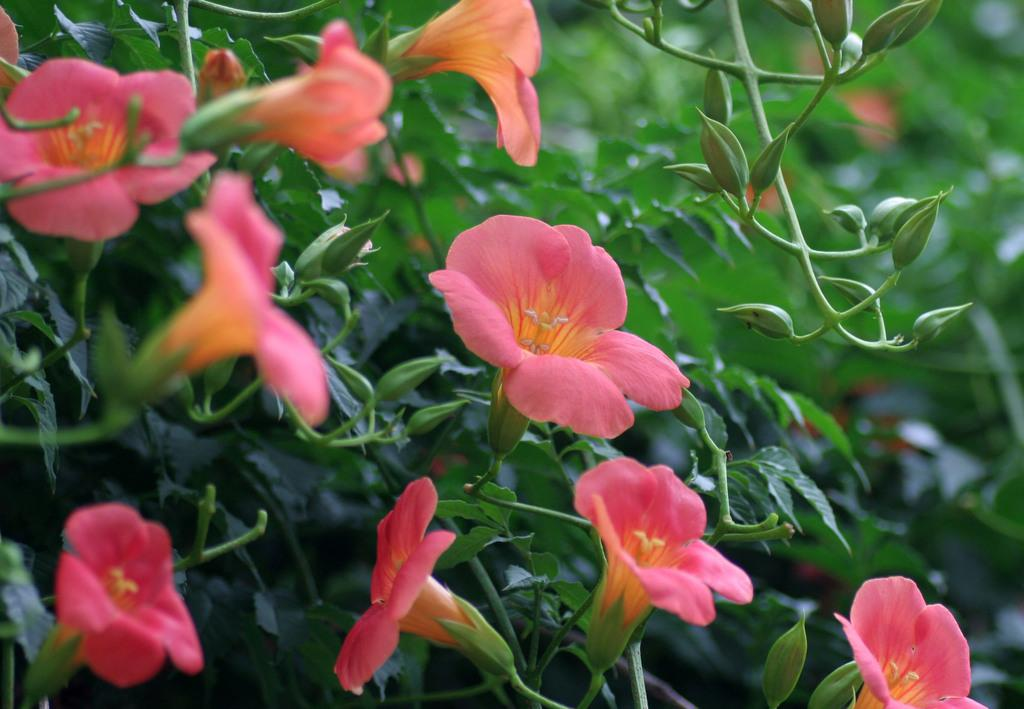What type of plant life can be seen in the image? There are flowers, buds, and leaves in the image. Can you describe the stage of growth for the plants in the image? The image shows both flowers and buds, indicating that some plants are in bloom while others are still developing. What is the appearance of the background in the image? The background of the image is blurred. What type of humor is being displayed by the flowers in the image? There is no humor being displayed by the flowers in the image; they are simply plants. 